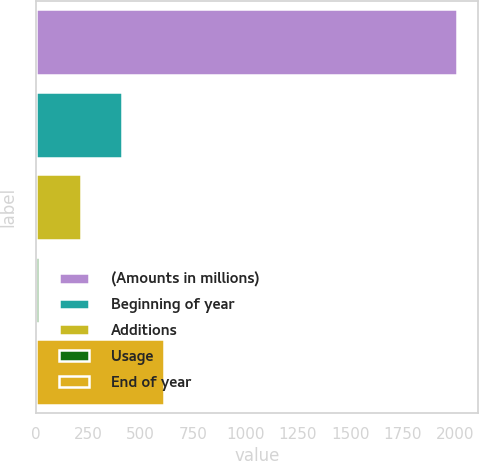Convert chart. <chart><loc_0><loc_0><loc_500><loc_500><bar_chart><fcel>(Amounts in millions)<fcel>Beginning of year<fcel>Additions<fcel>Usage<fcel>End of year<nl><fcel>2011<fcel>413.08<fcel>213.34<fcel>13.6<fcel>612.82<nl></chart> 